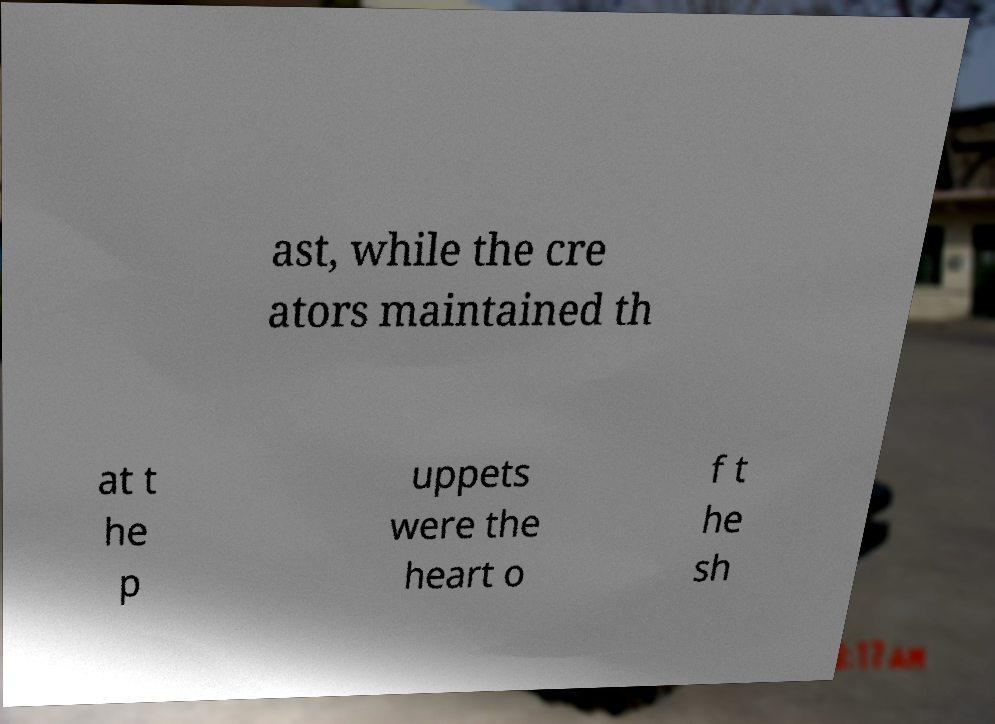Can you read and provide the text displayed in the image?This photo seems to have some interesting text. Can you extract and type it out for me? ast, while the cre ators maintained th at t he p uppets were the heart o f t he sh 